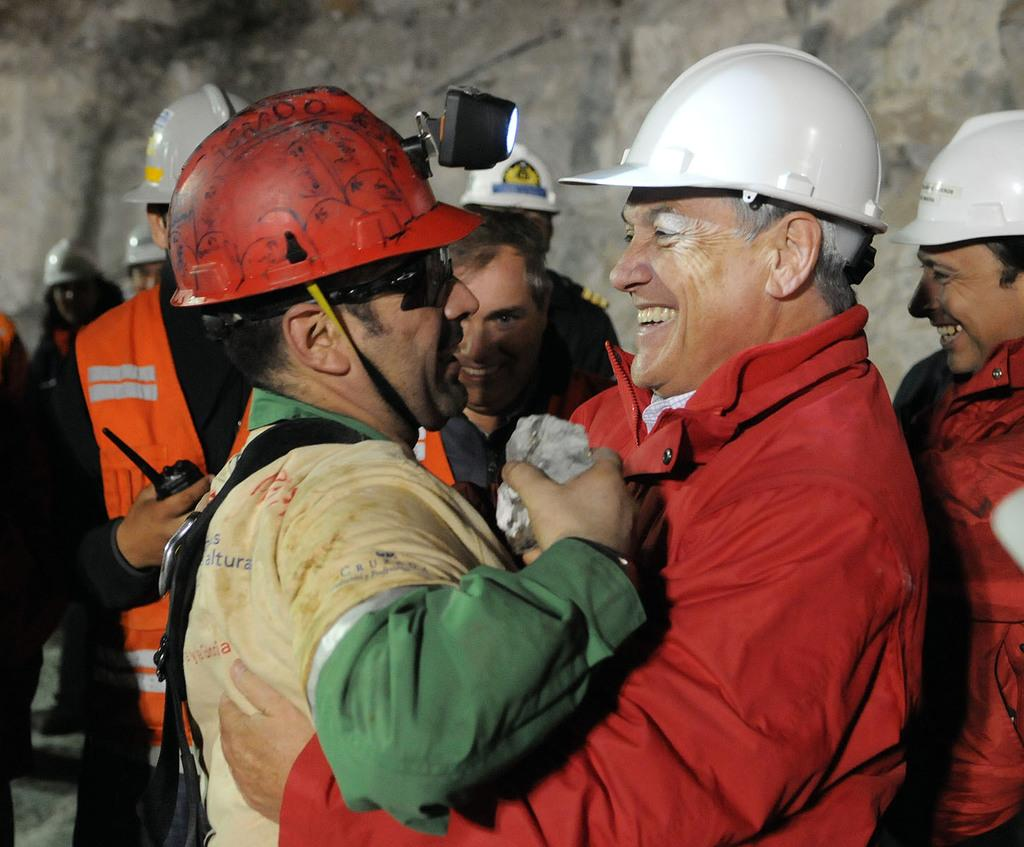How many people are in the image? There is a group of people in the image, but the exact number is not specified. What are the people doing in the image? The people are standing on the floor. What protective gear are the people wearing? The people are wearing helmets. What type of background can be seen in the image? There is a wall of stone in the background of the image. Can you determine the time of day the image was taken? The image is likely taken during the day, as there is no indication of darkness or artificial lighting. What type of potato is being used as a lawyer in the image? There is no potato or lawyer present in the image; it features a group of people wearing helmets and standing on the floor with a stone wall in the background. 